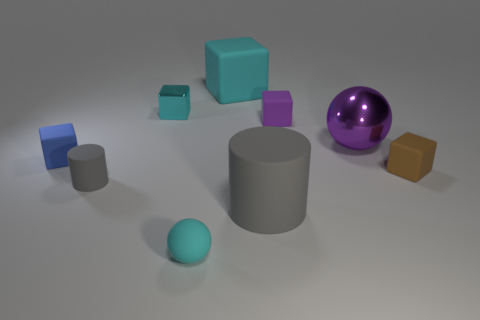What can you infer about the lighting in this scene? The scene is lit from above with a soft, diffused light source, as indicated by the gentle shadows under the objects and the subtle highlights on the tops and edges. The lack of harsh shadows suggests that the environment is softly lit, which allows for the textures and colors of the objects to be distinctly visible without strong contrasts. 